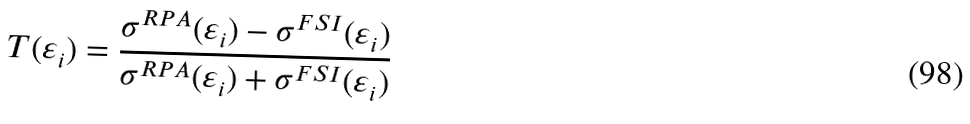<formula> <loc_0><loc_0><loc_500><loc_500>T ( \varepsilon _ { i } ) = \frac { \sigma ^ { R P A } ( \varepsilon _ { i } ) - \sigma ^ { F S I } ( \varepsilon _ { i } ) } { \sigma ^ { R P A } ( \varepsilon _ { i } ) + \sigma ^ { F S I } ( \varepsilon _ { i } ) }</formula> 